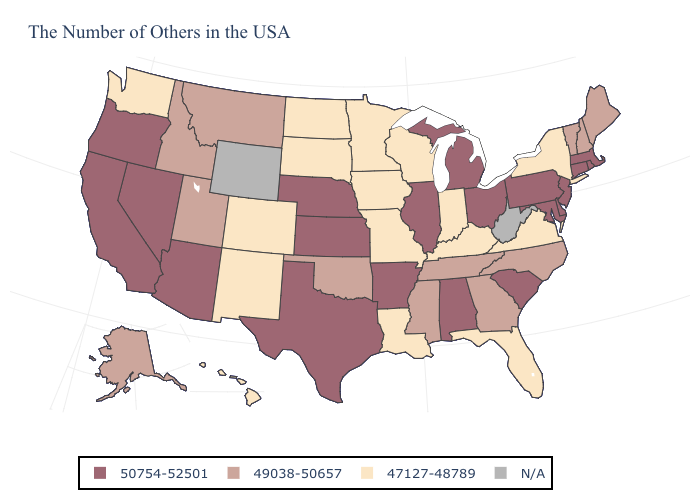What is the value of Maryland?
Answer briefly. 50754-52501. Name the states that have a value in the range 47127-48789?
Write a very short answer. New York, Virginia, Florida, Kentucky, Indiana, Wisconsin, Louisiana, Missouri, Minnesota, Iowa, South Dakota, North Dakota, Colorado, New Mexico, Washington, Hawaii. Among the states that border Florida , does Alabama have the highest value?
Write a very short answer. Yes. Name the states that have a value in the range 47127-48789?
Answer briefly. New York, Virginia, Florida, Kentucky, Indiana, Wisconsin, Louisiana, Missouri, Minnesota, Iowa, South Dakota, North Dakota, Colorado, New Mexico, Washington, Hawaii. What is the lowest value in the USA?
Give a very brief answer. 47127-48789. What is the lowest value in the MidWest?
Answer briefly. 47127-48789. What is the highest value in states that border Missouri?
Be succinct. 50754-52501. Does the map have missing data?
Answer briefly. Yes. Does Michigan have the highest value in the USA?
Write a very short answer. Yes. What is the value of Oklahoma?
Answer briefly. 49038-50657. Does Alaska have the highest value in the West?
Answer briefly. No. Does the map have missing data?
Be succinct. Yes. Is the legend a continuous bar?
Quick response, please. No. 